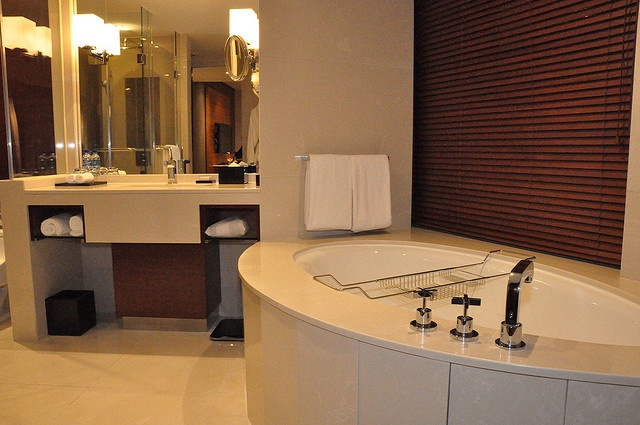Describe the objects in this image and their specific colors. I can see sink in olive, tan, and black tones, sink in olive, tan, and khaki tones, bottle in olive, gray, and tan tones, and bottle in olive, gray, and tan tones in this image. 